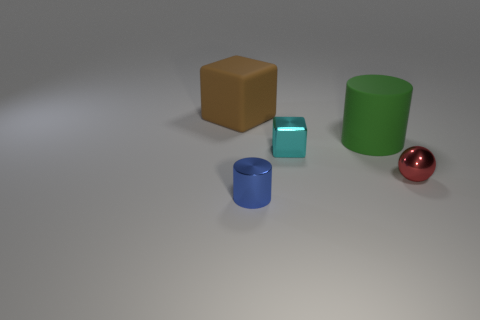Are there any patterns or textures on the objects? The objects in the image appear to have matte surfaces with no distinct patterns or textures visible. Each object has a uniform color and a smooth surface. 